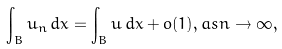<formula> <loc_0><loc_0><loc_500><loc_500>\int _ { B } u _ { n } \, d x = \int _ { B } u \, d x + o ( 1 ) , a s n \to \infty ,</formula> 